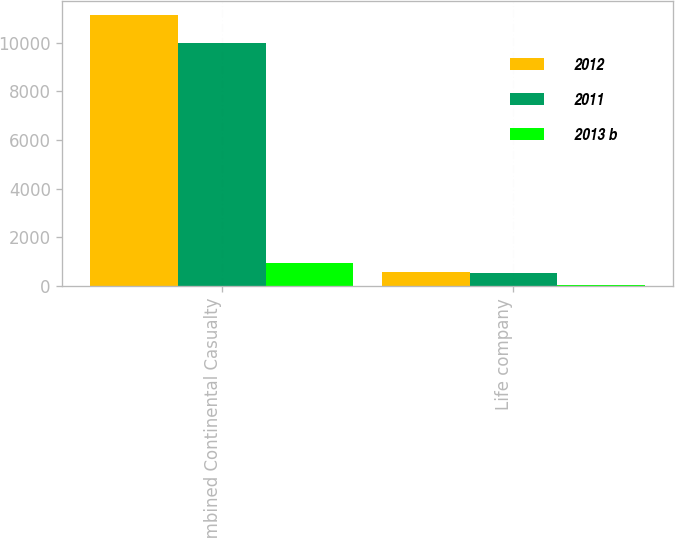<chart> <loc_0><loc_0><loc_500><loc_500><stacked_bar_chart><ecel><fcel>Combined Continental Casualty<fcel>Life company<nl><fcel>2012<fcel>11137<fcel>597<nl><fcel>2011<fcel>9998<fcel>556<nl><fcel>2013 b<fcel>954<fcel>29<nl></chart> 